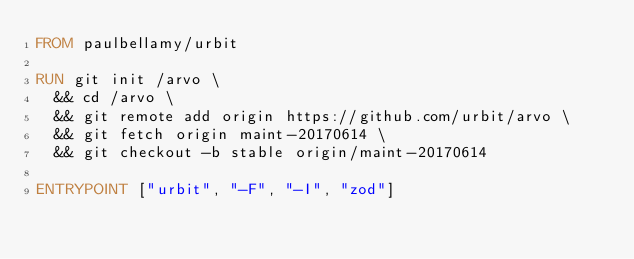<code> <loc_0><loc_0><loc_500><loc_500><_Dockerfile_>FROM paulbellamy/urbit

RUN git init /arvo \
  && cd /arvo \
  && git remote add origin https://github.com/urbit/arvo \
  && git fetch origin maint-20170614 \
  && git checkout -b stable origin/maint-20170614

ENTRYPOINT ["urbit", "-F", "-I", "zod"]
</code> 